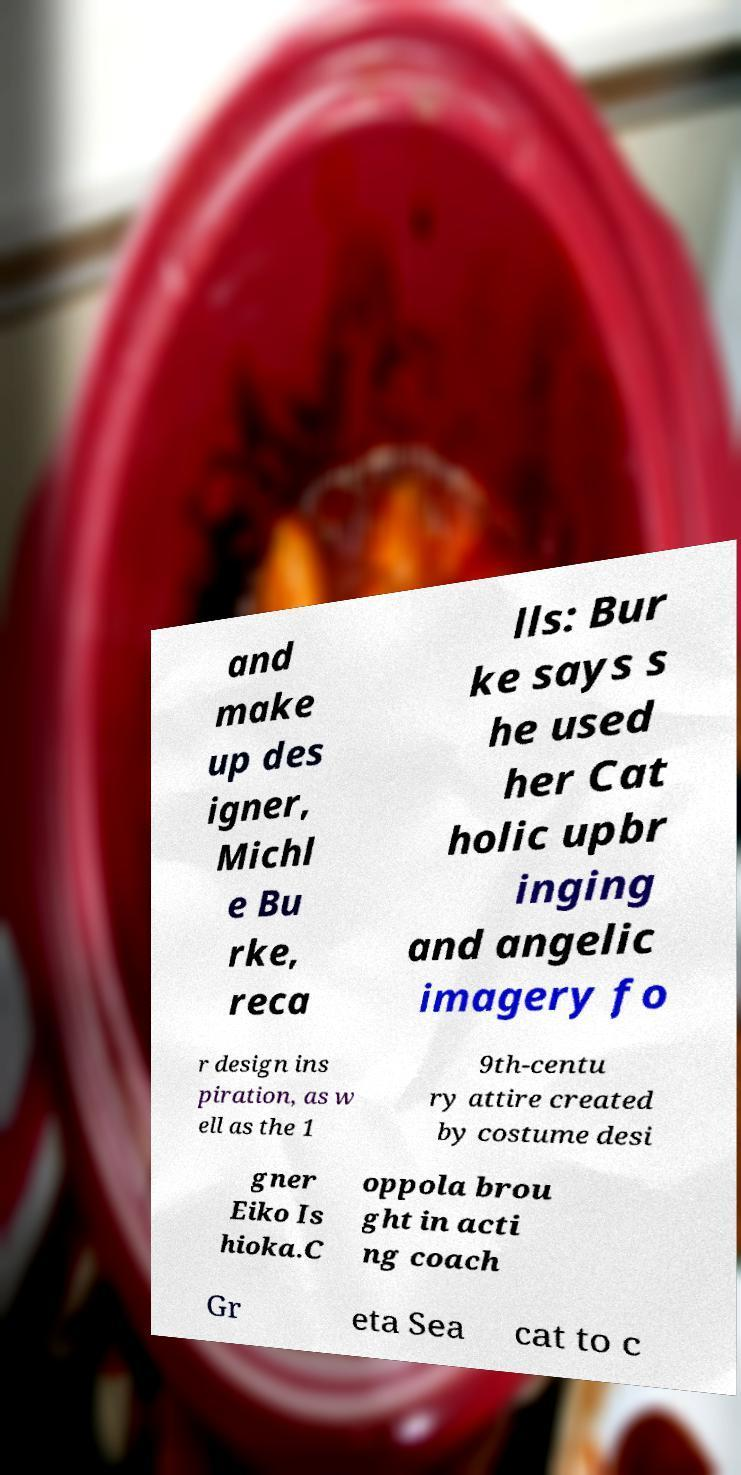Could you assist in decoding the text presented in this image and type it out clearly? and make up des igner, Michl e Bu rke, reca lls: Bur ke says s he used her Cat holic upbr inging and angelic imagery fo r design ins piration, as w ell as the 1 9th-centu ry attire created by costume desi gner Eiko Is hioka.C oppola brou ght in acti ng coach Gr eta Sea cat to c 